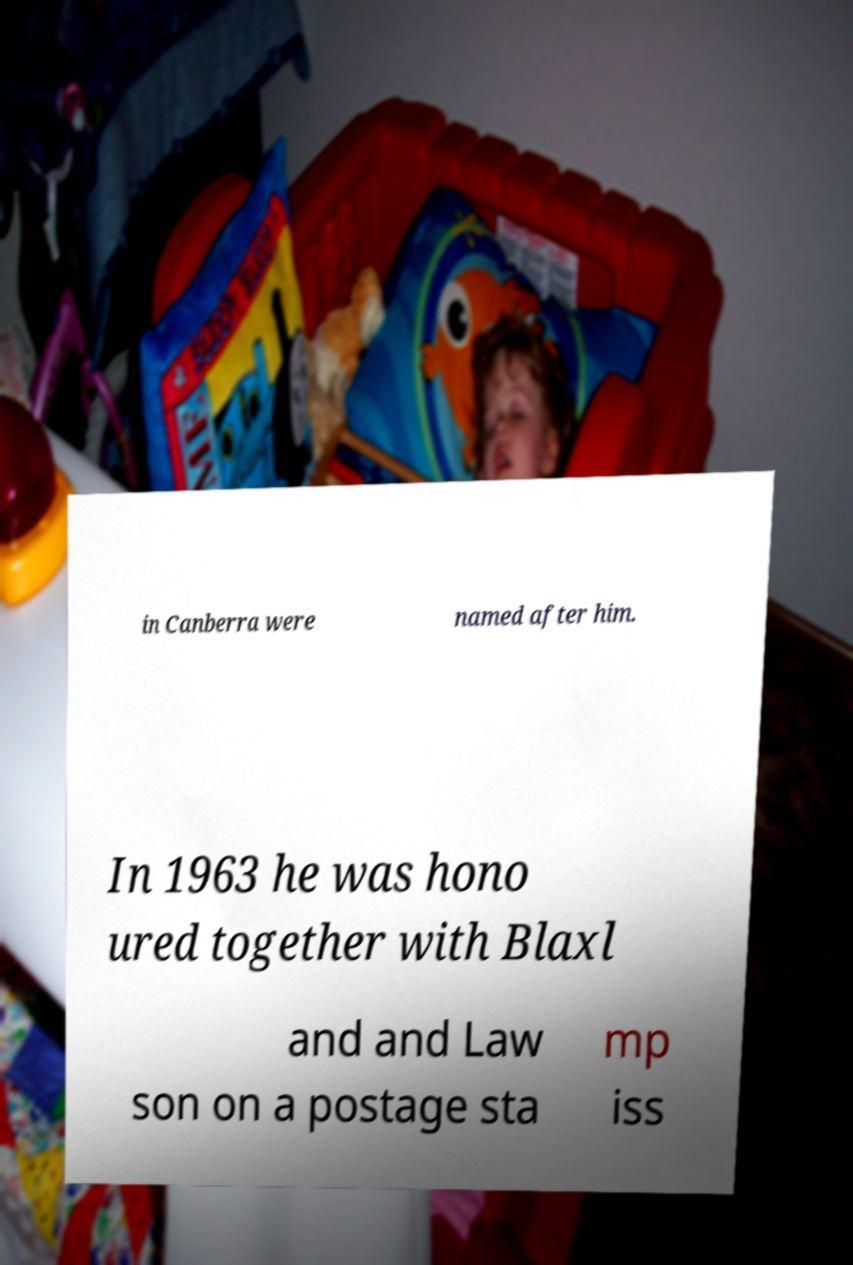Can you accurately transcribe the text from the provided image for me? in Canberra were named after him. In 1963 he was hono ured together with Blaxl and and Law son on a postage sta mp iss 